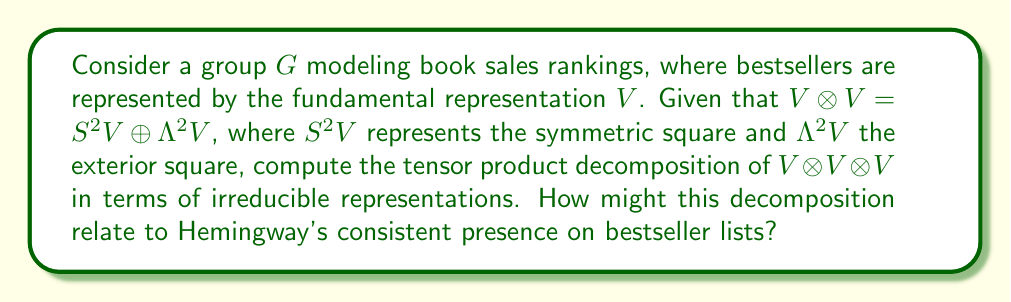What is the answer to this math problem? To compute the tensor product decomposition of $V \otimes V \otimes V$, we follow these steps:

1) We start with $V \otimes V \otimes V = (V \otimes V) \otimes V$

2) Using the given decomposition $V \otimes V = S^2V \oplus \Lambda^2V$, we substitute:
   $(S^2V \oplus \Lambda^2V) \otimes V$

3) Distribute the tensor product:
   $(S^2V \otimes V) \oplus (\Lambda^2V \otimes V)$

4) Now, we need to decompose $S^2V \otimes V$ and $\Lambda^2V \otimes V$. For a general representation theory result:
   $S^2V \otimes V = S^3V \oplus V_{\text{mixed}}$
   $\Lambda^2V \otimes V = \Lambda^3V \oplus V_{\text{mixed}}$

   Where $V_{\text{mixed}}$ is a representation with mixed symmetry.

5) Substituting these decompositions:
   $(S^3V \oplus V_{\text{mixed}}) \oplus (\Lambda^3V \oplus V_{\text{mixed}})$

6) Simplifying:
   $S^3V \oplus \Lambda^3V \oplus 2V_{\text{mixed}}$

This decomposition can be interpreted in the context of bestseller lists:
- $S^3V$ might represent books consistently at the top (like Hemingway's works)
- $\Lambda^3V$ could represent books with rapidly changing rankings
- $2V_{\text{mixed}}$ might represent books with more complex ranking patterns

Hemingway's consistent presence on bestseller lists would be reflected in the $S^3V$ component, showcasing the enduring popularity of his works.
Answer: $V \otimes V \otimes V = S^3V \oplus \Lambda^3V \oplus 2V_{\text{mixed}}$ 